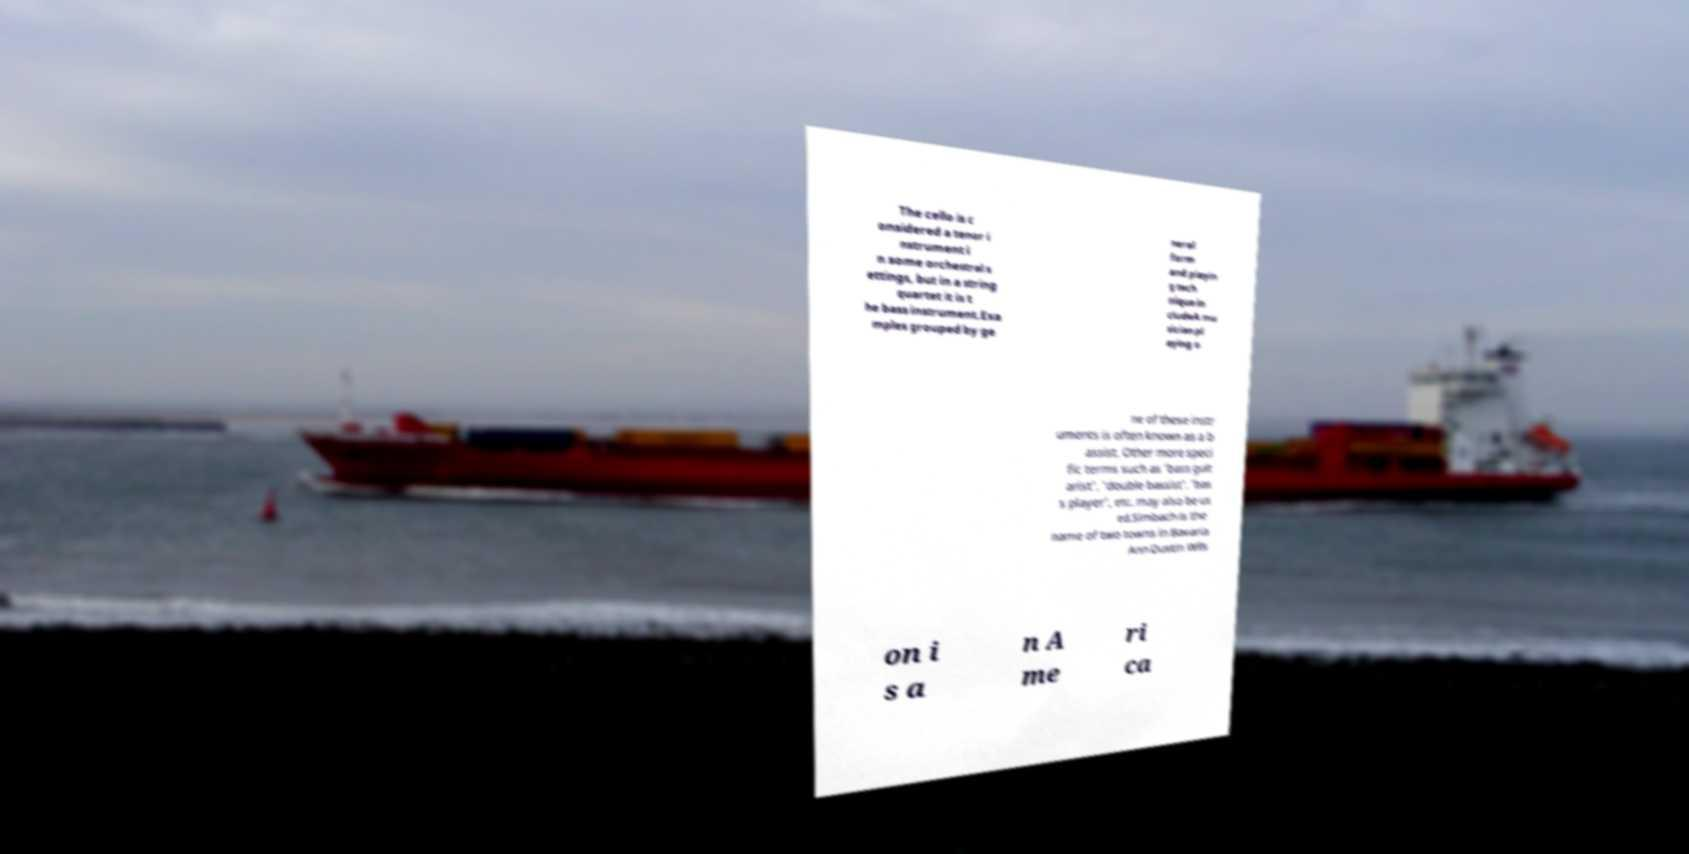I need the written content from this picture converted into text. Can you do that? The cello is c onsidered a tenor i nstrument i n some orchestral s ettings, but in a string quartet it is t he bass instrument.Exa mples grouped by ge neral form and playin g tech nique in cludeA mu sician pl aying o ne of these instr uments is often known as a b assist. Other more speci fic terms such as 'bass guit arist', 'double bassist', 'bas s player', etc. may also be us ed.Simbach is the name of two towns in Bavaria Ann Dustin Wils on i s a n A me ri ca 